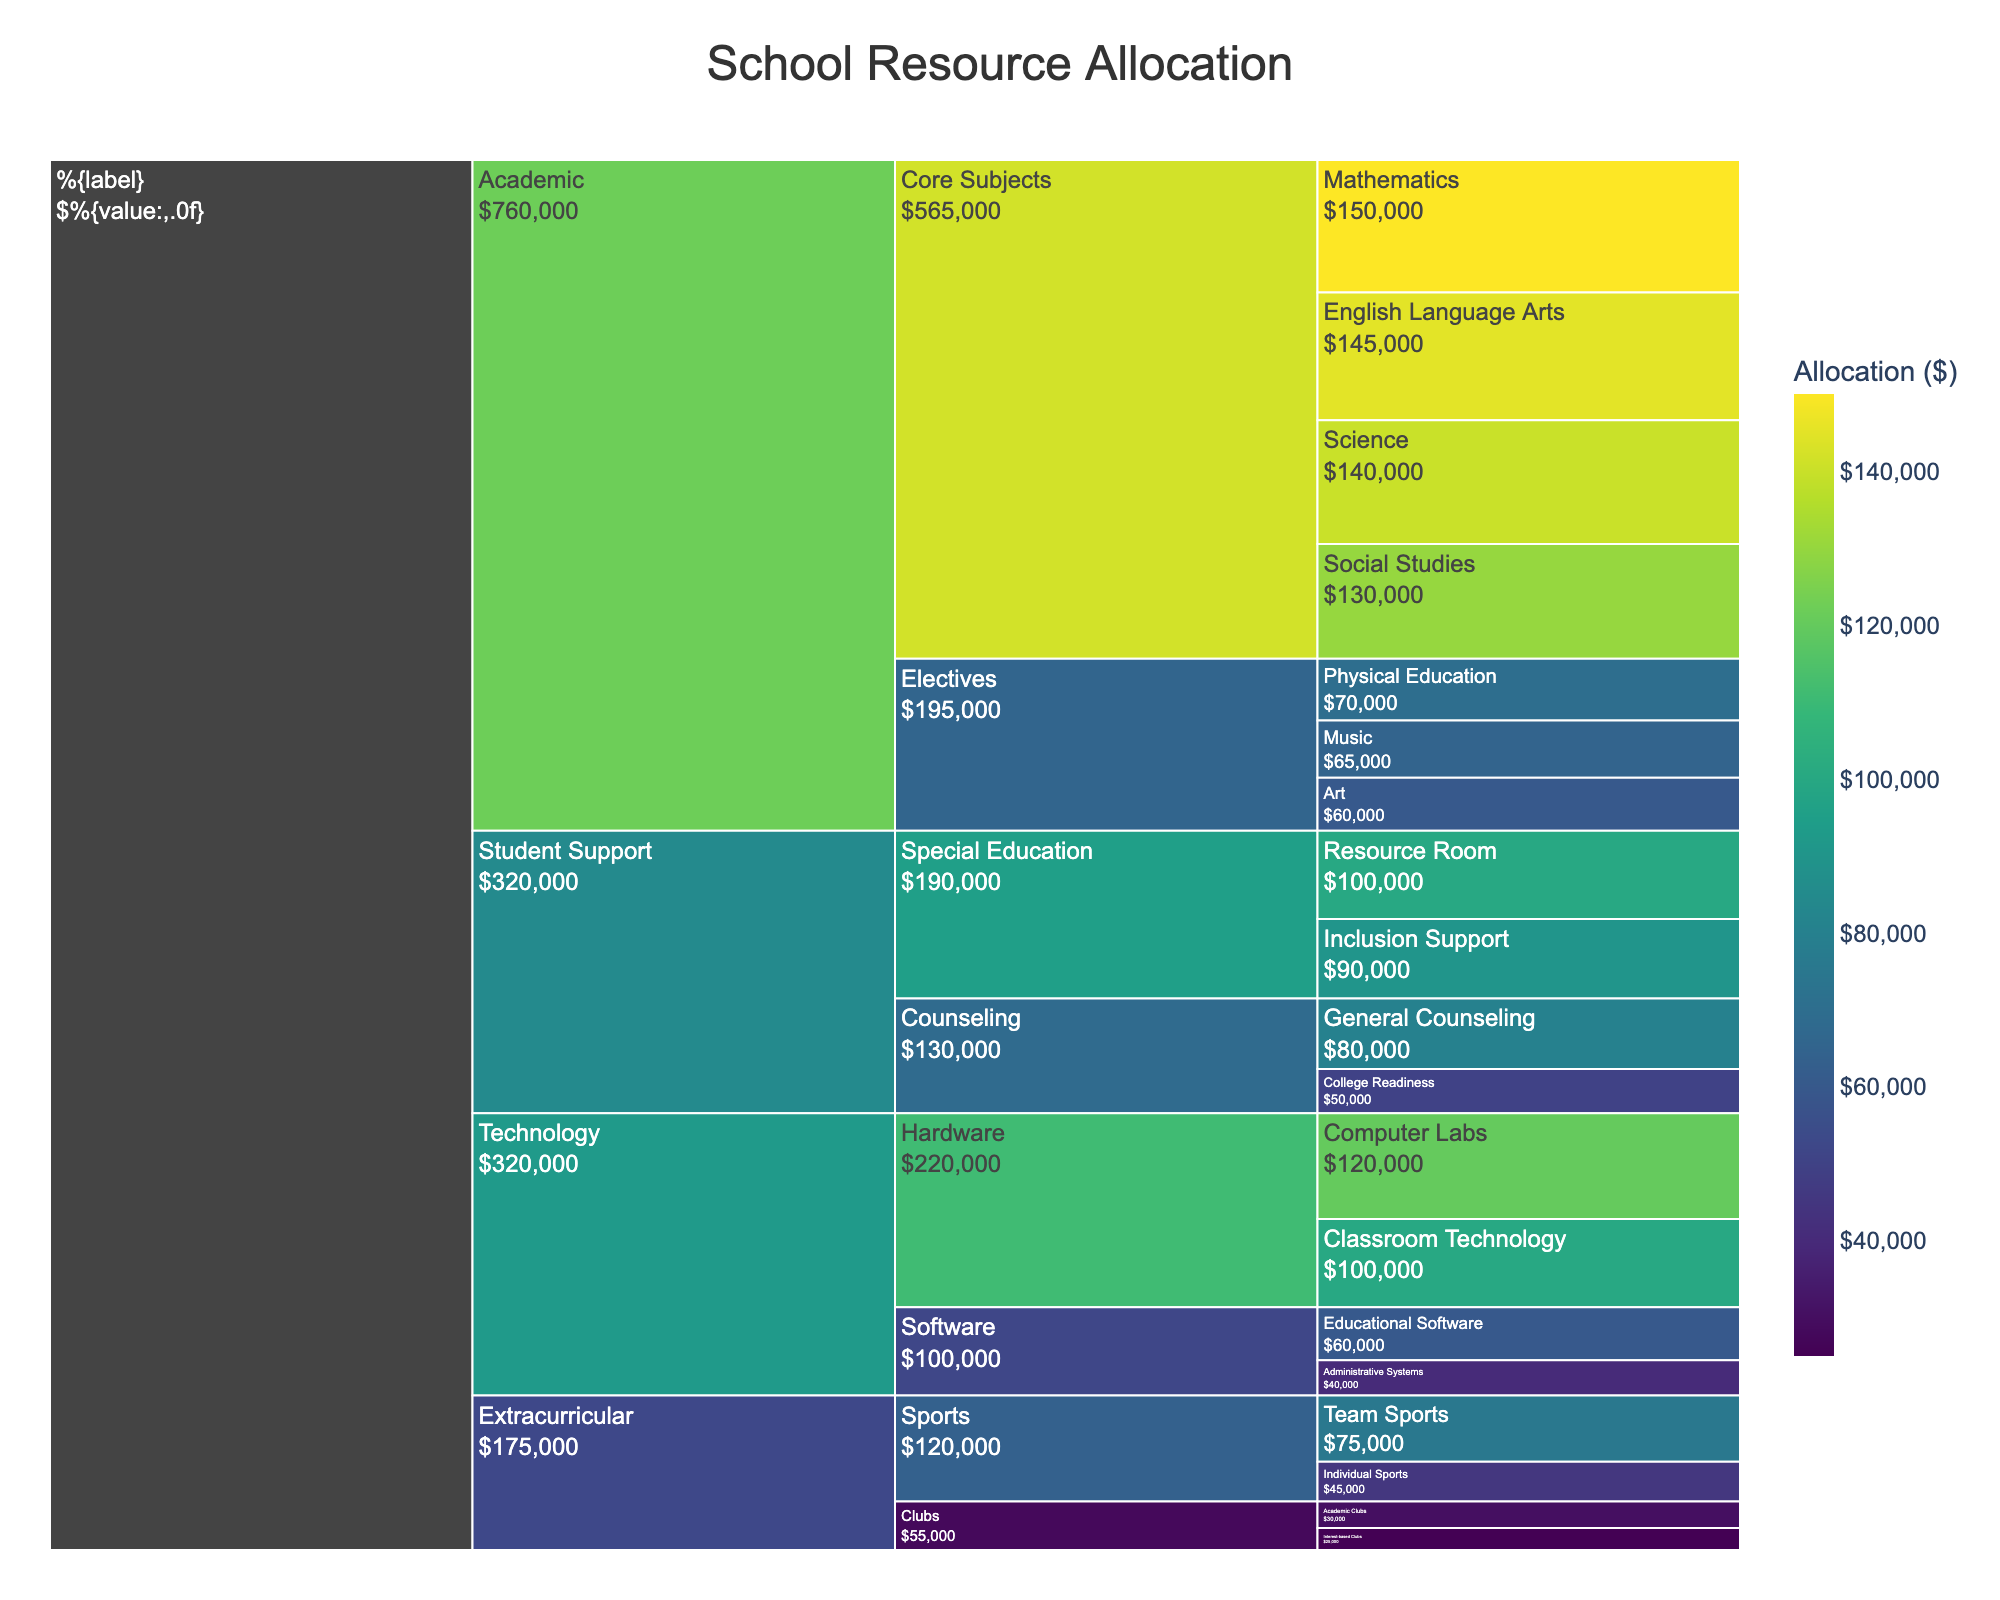What is the total allocation for Core Subjects in the Academic category? Sum the allocations for Mathematics ($150,000), English Language Arts ($145,000), Science ($140,000), and Social Studies ($130,000). The total is $565,000.
Answer: $565,000 Which program has the highest allocation in the Student Support category? Look at the allocations in Student Support: General Counseling ($80,000), College Readiness ($50,000), Resource Room ($100,000), and Inclusion Support ($90,000). Resource Room has the highest allocation with $100,000.
Answer: Resource Room How much more is allocated to Computer Labs compared to Administrative Systems in the Technology category? Computer Labs have an allocation of $120,000, while Administrative Systems have $40,000. The difference is $120,000 - $40,000 = $80,000.
Answer: $80,000 What is the total allocation for programs under the Extracurricular category? Sum the allocations for Team Sports ($75,000), Individual Sports ($45,000), Academic Clubs ($30,000), and Interest-based Clubs ($25,000). The total is $175,000.
Answer: $175,000 Between Academic and Technology categories, which one has a higher total allocation? Sum the allocations for Academic (Core Subjects: $565,000; Electives: $195,000; Total: $760,000) and Technology (Hardware: $220,000; Software: $100,000; Total: $320,000). Academic has a higher total allocation with $760,000.
Answer: Academic In the Academic category, which Elective program has the highest allocation? Compare the allocations in the Elective subcategory: Art ($60,000), Music ($65,000), and Physical Education ($70,000). Physical Education has the highest allocation with $70,000.
Answer: Physical Education What is the percentage allocation of Mathematics in the Academic category? Total allocation for Academic is $760,000. Allocation for Mathematics is $150,000. The percentage is (150,000 / 760,000) * 100 = 19.74%.
Answer: 19.74% Which category has the least total allocation? Sum the total allocations for each category: Academic ($760,000), Student Support ($320,000), Extracurricular ($175,000), Technology ($320,000). Extracurricular has the least total allocation with $175,000.
Answer: Extracurricular What is the total allocation for the Technology category’s Hardware subcategory? Sum the allocations for Computer Labs ($120,000) and Classroom Technology ($100,000). The total is $220,000.
Answer: $220,000 